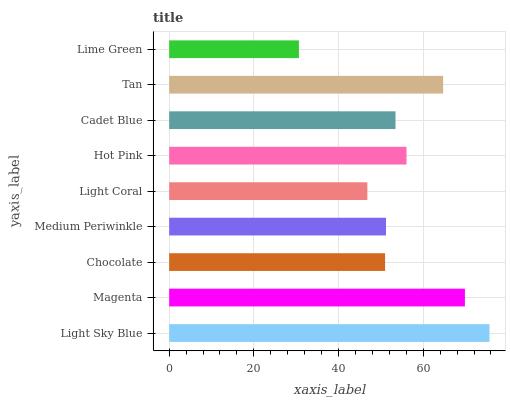Is Lime Green the minimum?
Answer yes or no. Yes. Is Light Sky Blue the maximum?
Answer yes or no. Yes. Is Magenta the minimum?
Answer yes or no. No. Is Magenta the maximum?
Answer yes or no. No. Is Light Sky Blue greater than Magenta?
Answer yes or no. Yes. Is Magenta less than Light Sky Blue?
Answer yes or no. Yes. Is Magenta greater than Light Sky Blue?
Answer yes or no. No. Is Light Sky Blue less than Magenta?
Answer yes or no. No. Is Cadet Blue the high median?
Answer yes or no. Yes. Is Cadet Blue the low median?
Answer yes or no. Yes. Is Magenta the high median?
Answer yes or no. No. Is Magenta the low median?
Answer yes or no. No. 